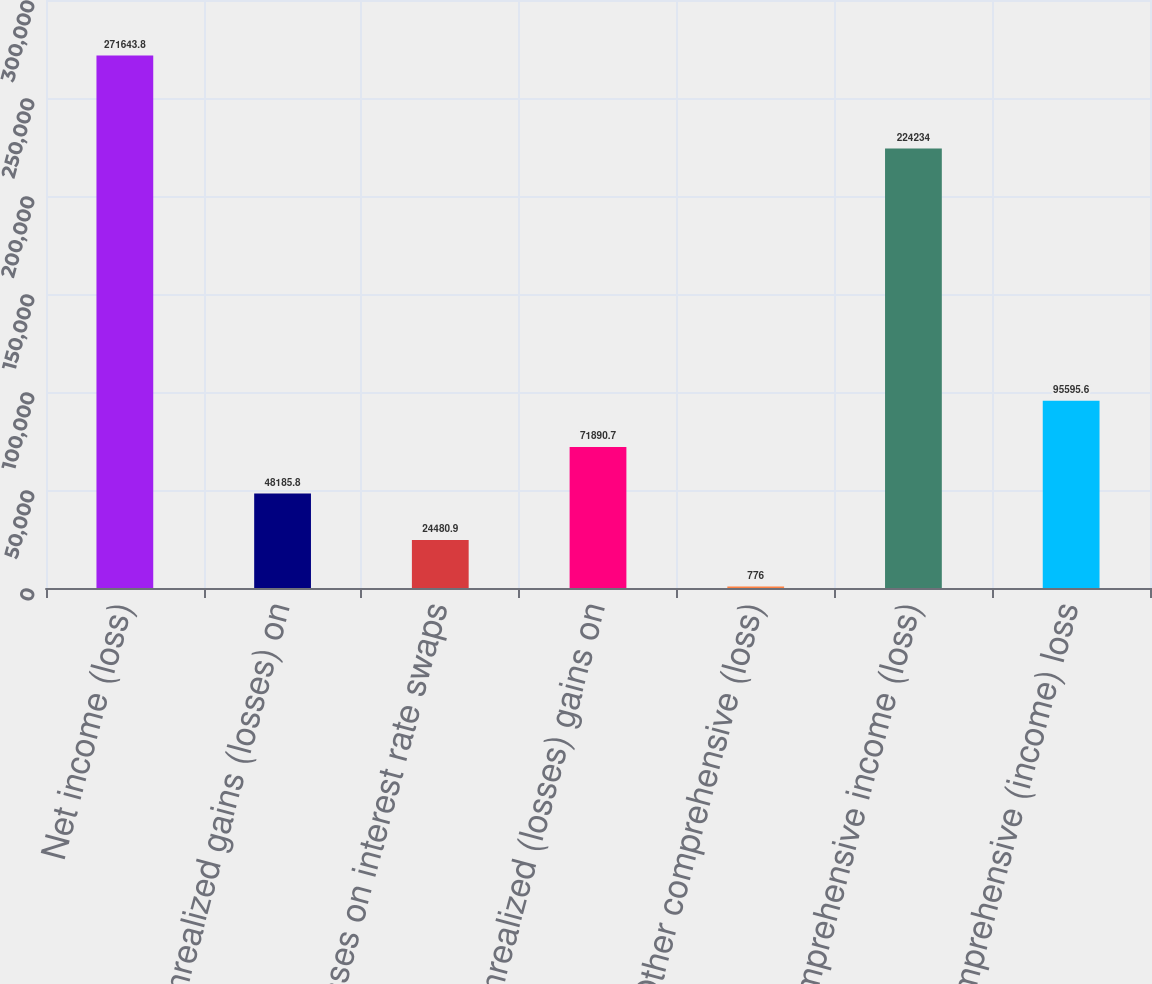<chart> <loc_0><loc_0><loc_500><loc_500><bar_chart><fcel>Net income (loss)<fcel>Unrealized gains (losses) on<fcel>Losses on interest rate swaps<fcel>Unrealized (losses) gains on<fcel>Other comprehensive (loss)<fcel>Comprehensive income (loss)<fcel>Comprehensive (income) loss<nl><fcel>271644<fcel>48185.8<fcel>24480.9<fcel>71890.7<fcel>776<fcel>224234<fcel>95595.6<nl></chart> 